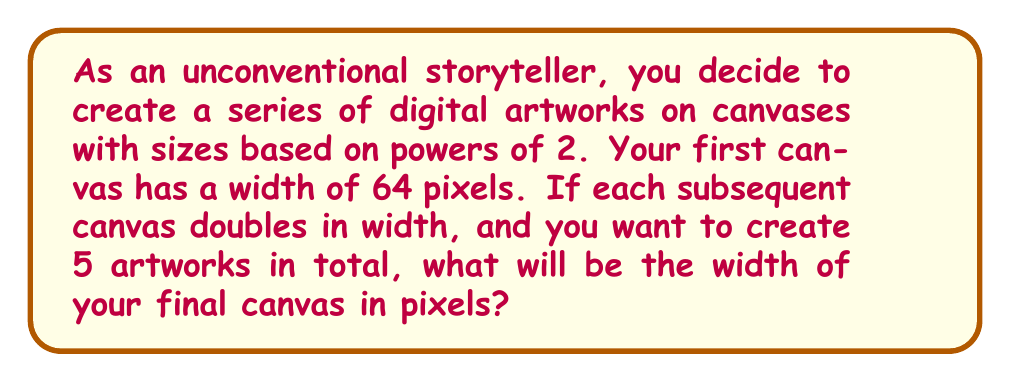Help me with this question. Let's approach this step-by-step:

1) The initial canvas width is 64 pixels.

2) We know that 64 is already a power of 2:
   $64 = 2^6$

3) For each subsequent canvas, we double the width. In terms of exponents, this means we increase the power of 2 by 1 each time.

4) We need 5 artworks in total, so we'll be increasing the power 4 times from our starting point.

5) We can represent this mathematically as:
   $\text{Final width} = 2^{6+4} = 2^{10}$

6) Calculate $2^{10}$:
   $2^{10} = 2 \times 2 \times 2 \times 2 \times 2 \times 2 \times 2 \times 2 \times 2 \times 2 = 1024$

Therefore, the width of the final canvas will be 1024 pixels.
Answer: 1024 pixels 